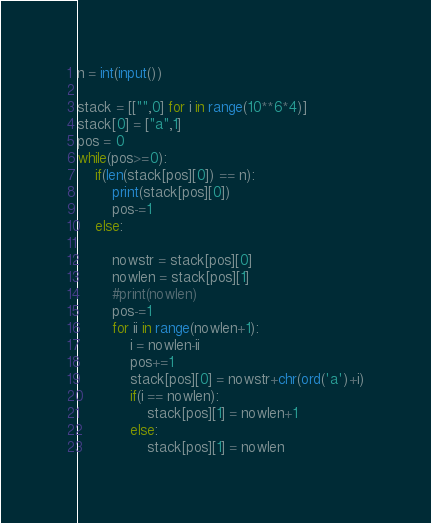<code> <loc_0><loc_0><loc_500><loc_500><_Python_>
n = int(input())

stack = [["",0] for i in range(10**6*4)]
stack[0] = ["a",1]
pos = 0    
while(pos>=0):
    if(len(stack[pos][0]) == n):
        print(stack[pos][0])
        pos-=1
    else:
        
        nowstr = stack[pos][0]
        nowlen = stack[pos][1]
        #print(nowlen)
        pos-=1
        for ii in range(nowlen+1):
            i = nowlen-ii
            pos+=1
            stack[pos][0] = nowstr+chr(ord('a')+i)
            if(i == nowlen):
                stack[pos][1] = nowlen+1
            else:
                stack[pos][1] = nowlen



</code> 